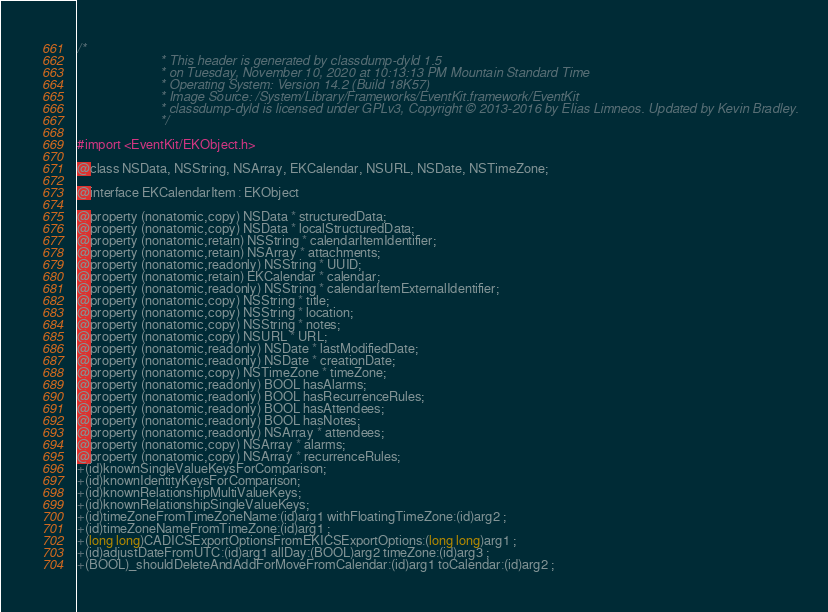Convert code to text. <code><loc_0><loc_0><loc_500><loc_500><_C_>/*
                       * This header is generated by classdump-dyld 1.5
                       * on Tuesday, November 10, 2020 at 10:13:13 PM Mountain Standard Time
                       * Operating System: Version 14.2 (Build 18K57)
                       * Image Source: /System/Library/Frameworks/EventKit.framework/EventKit
                       * classdump-dyld is licensed under GPLv3, Copyright © 2013-2016 by Elias Limneos. Updated by Kevin Bradley.
                       */

#import <EventKit/EKObject.h>

@class NSData, NSString, NSArray, EKCalendar, NSURL, NSDate, NSTimeZone;

@interface EKCalendarItem : EKObject

@property (nonatomic,copy) NSData * structuredData; 
@property (nonatomic,copy) NSData * localStructuredData; 
@property (nonatomic,retain) NSString * calendarItemIdentifier; 
@property (nonatomic,retain) NSArray * attachments; 
@property (nonatomic,readonly) NSString * UUID; 
@property (nonatomic,retain) EKCalendar * calendar; 
@property (nonatomic,readonly) NSString * calendarItemExternalIdentifier; 
@property (nonatomic,copy) NSString * title; 
@property (nonatomic,copy) NSString * location; 
@property (nonatomic,copy) NSString * notes; 
@property (nonatomic,copy) NSURL * URL; 
@property (nonatomic,readonly) NSDate * lastModifiedDate; 
@property (nonatomic,readonly) NSDate * creationDate; 
@property (nonatomic,copy) NSTimeZone * timeZone; 
@property (nonatomic,readonly) BOOL hasAlarms; 
@property (nonatomic,readonly) BOOL hasRecurrenceRules; 
@property (nonatomic,readonly) BOOL hasAttendees; 
@property (nonatomic,readonly) BOOL hasNotes; 
@property (nonatomic,readonly) NSArray * attendees; 
@property (nonatomic,copy) NSArray * alarms; 
@property (nonatomic,copy) NSArray * recurrenceRules; 
+(id)knownSingleValueKeysForComparison;
+(id)knownIdentityKeysForComparison;
+(id)knownRelationshipMultiValueKeys;
+(id)knownRelationshipSingleValueKeys;
+(id)timeZoneFromTimeZoneName:(id)arg1 withFloatingTimeZone:(id)arg2 ;
+(id)timeZoneNameFromTimeZone:(id)arg1 ;
+(long long)CADICSExportOptionsFromEKICSExportOptions:(long long)arg1 ;
+(id)adjustDateFromUTC:(id)arg1 allDay:(BOOL)arg2 timeZone:(id)arg3 ;
+(BOOL)_shouldDeleteAndAddForMoveFromCalendar:(id)arg1 toCalendar:(id)arg2 ;</code> 